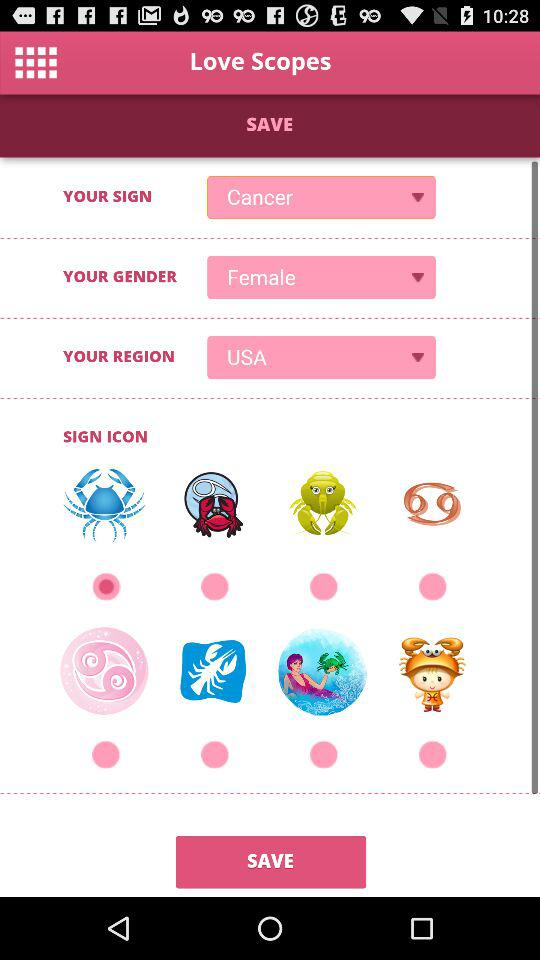What is "YOUR SIGN"? "YOUR SIGN" is Cancer. 